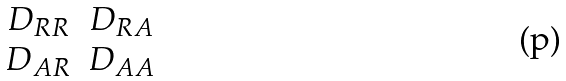Convert formula to latex. <formula><loc_0><loc_0><loc_500><loc_500>\begin{matrix} D _ { R R } & D _ { R A } \\ D _ { A R } & D _ { A A } \end{matrix}</formula> 